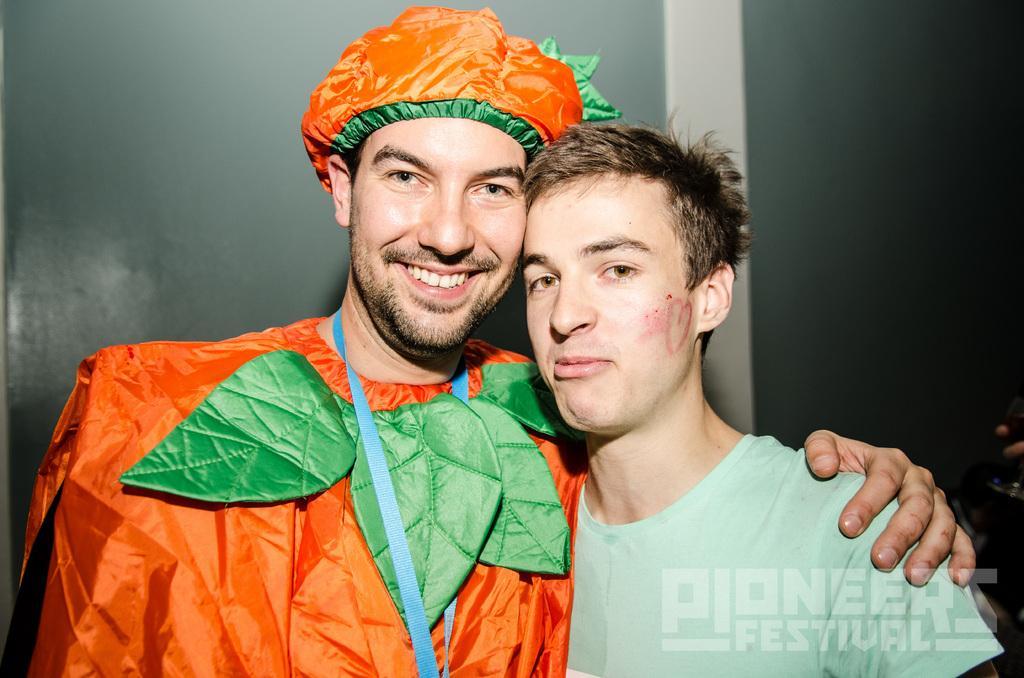In one or two sentences, can you explain what this image depicts? In this image, there are a few people. Among them, we can see a person wearing a costume. In the background, we can see the wall. We can also see some text on the bottom right. 